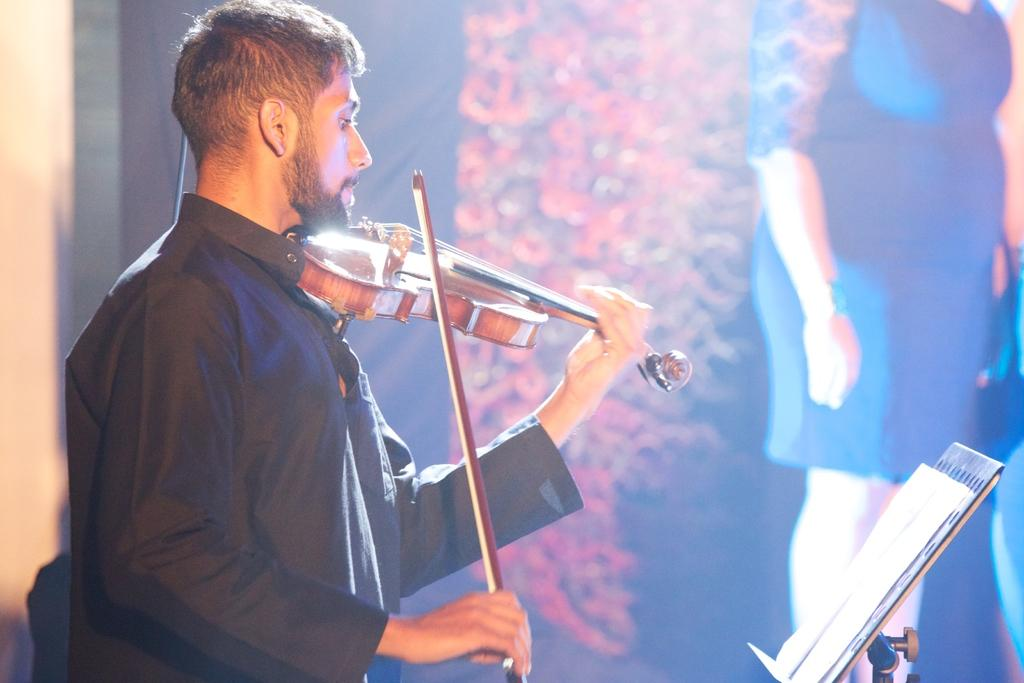What is the man in the image doing? The man is playing a guitar. What is the man wearing in the image? The man is wearing a black color shirt. What else can be seen in the image besides the man and his guitar? There is a book in the image. What type of flowers can be seen growing around the man's feet in the image? There are no flowers visible in the image, and the man's feet are not mentioned in the provided facts. What shape is the guitar in the image? The shape of the guitar is not mentioned in the provided facts, so it cannot be determined from the image. 